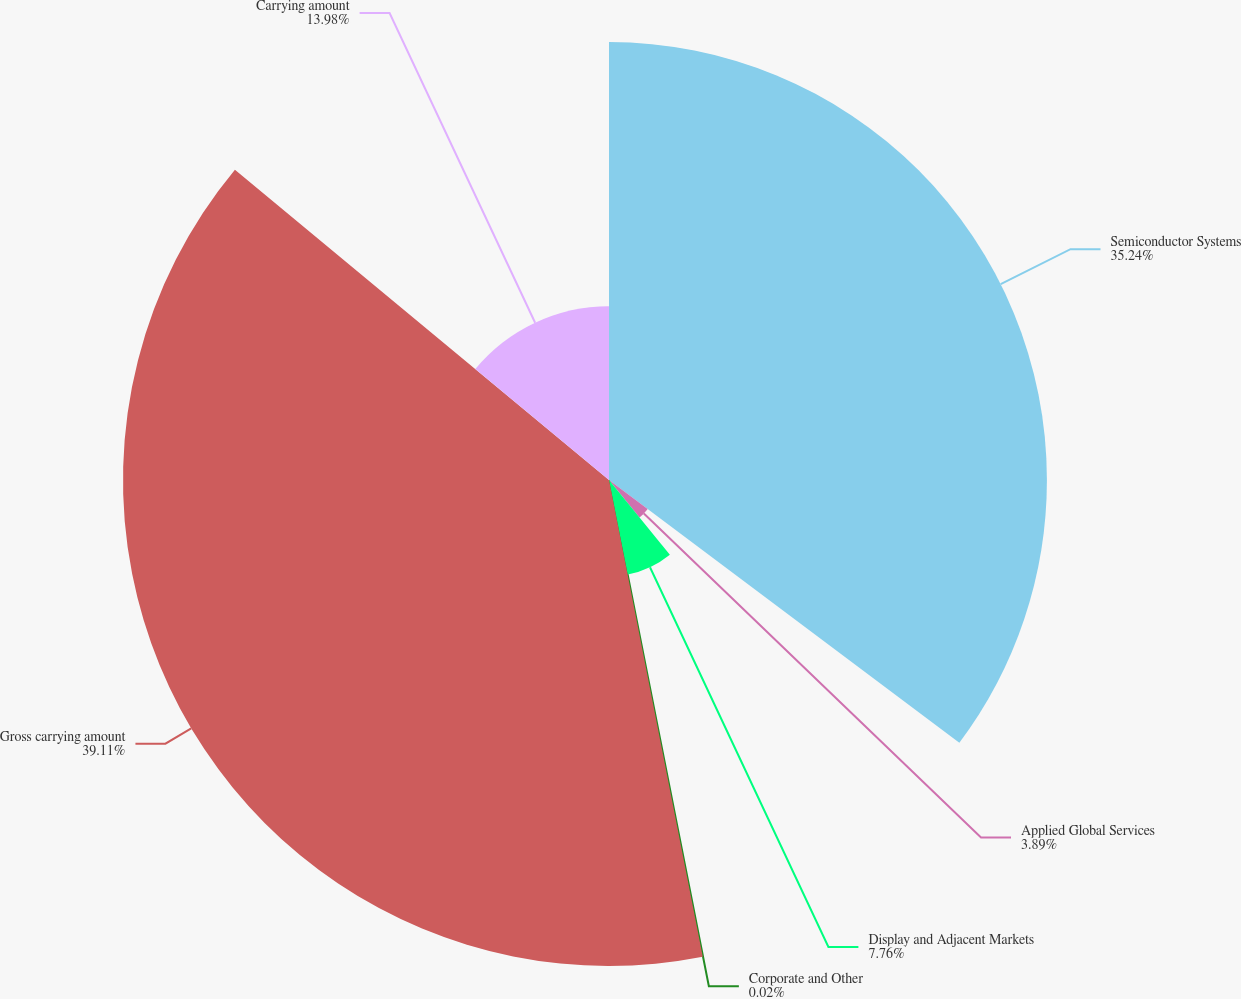Convert chart to OTSL. <chart><loc_0><loc_0><loc_500><loc_500><pie_chart><fcel>Semiconductor Systems<fcel>Applied Global Services<fcel>Display and Adjacent Markets<fcel>Corporate and Other<fcel>Gross carrying amount<fcel>Carrying amount<nl><fcel>35.24%<fcel>3.89%<fcel>7.76%<fcel>0.02%<fcel>39.11%<fcel>13.98%<nl></chart> 